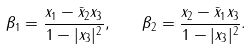Convert formula to latex. <formula><loc_0><loc_0><loc_500><loc_500>\beta _ { 1 } = \frac { x _ { 1 } - \bar { x } _ { 2 } x _ { 3 } } { 1 - | x _ { 3 } | ^ { 2 } } , \quad \beta _ { 2 } = \frac { x _ { 2 } - \bar { x } _ { 1 } x _ { 3 } } { 1 - | x _ { 3 } | ^ { 2 } } .</formula> 